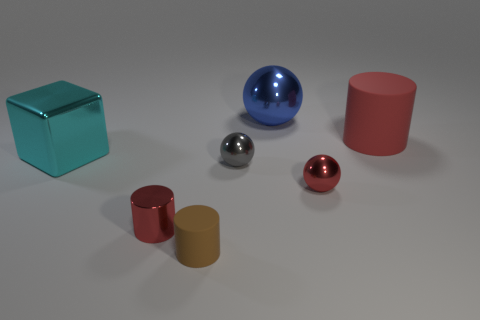Add 2 small blue rubber cubes. How many objects exist? 9 Subtract all blocks. How many objects are left? 6 Add 2 brown cylinders. How many brown cylinders are left? 3 Add 6 large balls. How many large balls exist? 7 Subtract 0 green cubes. How many objects are left? 7 Subtract all gray metallic spheres. Subtract all small blue cylinders. How many objects are left? 6 